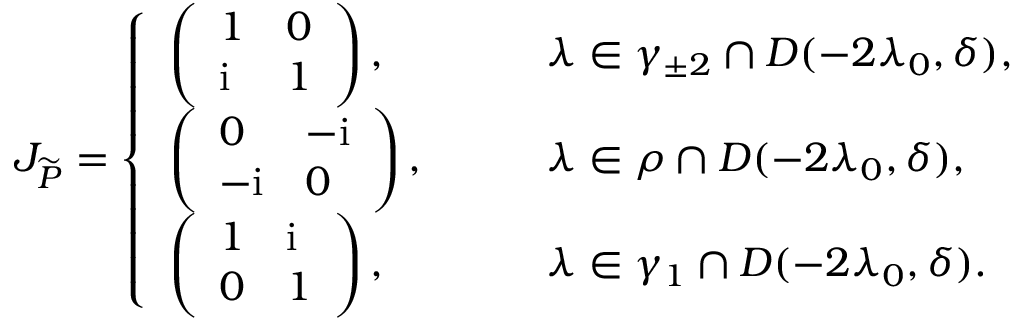Convert formula to latex. <formula><loc_0><loc_0><loc_500><loc_500>J _ { \widetilde { P } } = \left \{ \begin{array} { l l } { \left ( \begin{array} { l l } { 1 } & { 0 } \\ { i } & { 1 } \end{array} \right ) , } & { \quad \lambda \in \gamma _ { \pm 2 } \cap D ( - 2 \lambda _ { 0 } , \delta ) , } \\ { \left ( \begin{array} { l l } { 0 } & { - i } \\ { - i } & { 0 } \end{array} \right ) , } & { \quad \lambda \in \rho \cap D ( - 2 \lambda _ { 0 } , \delta ) , } \\ { \left ( \begin{array} { l l } { 1 } & { i } \\ { 0 } & { 1 } \end{array} \right ) , } & { \quad \lambda \in \gamma _ { 1 } \cap D ( - 2 \lambda _ { 0 } , \delta ) . } \end{array}</formula> 